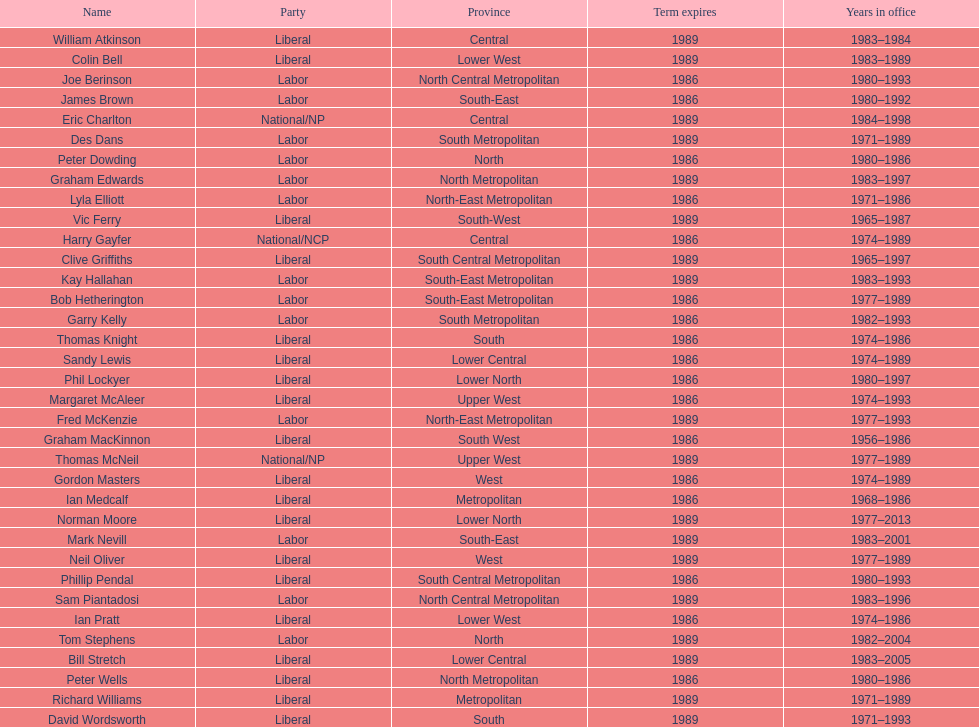Can you parse all the data within this table? {'header': ['Name', 'Party', 'Province', 'Term expires', 'Years in office'], 'rows': [['William Atkinson', 'Liberal', 'Central', '1989', '1983–1984'], ['Colin Bell', 'Liberal', 'Lower West', '1989', '1983–1989'], ['Joe Berinson', 'Labor', 'North Central Metropolitan', '1986', '1980–1993'], ['James Brown', 'Labor', 'South-East', '1986', '1980–1992'], ['Eric Charlton', 'National/NP', 'Central', '1989', '1984–1998'], ['Des Dans', 'Labor', 'South Metropolitan', '1989', '1971–1989'], ['Peter Dowding', 'Labor', 'North', '1986', '1980–1986'], ['Graham Edwards', 'Labor', 'North Metropolitan', '1989', '1983–1997'], ['Lyla Elliott', 'Labor', 'North-East Metropolitan', '1986', '1971–1986'], ['Vic Ferry', 'Liberal', 'South-West', '1989', '1965–1987'], ['Harry Gayfer', 'National/NCP', 'Central', '1986', '1974–1989'], ['Clive Griffiths', 'Liberal', 'South Central Metropolitan', '1989', '1965–1997'], ['Kay Hallahan', 'Labor', 'South-East Metropolitan', '1989', '1983–1993'], ['Bob Hetherington', 'Labor', 'South-East Metropolitan', '1986', '1977–1989'], ['Garry Kelly', 'Labor', 'South Metropolitan', '1986', '1982–1993'], ['Thomas Knight', 'Liberal', 'South', '1986', '1974–1986'], ['Sandy Lewis', 'Liberal', 'Lower Central', '1986', '1974–1989'], ['Phil Lockyer', 'Liberal', 'Lower North', '1986', '1980–1997'], ['Margaret McAleer', 'Liberal', 'Upper West', '1986', '1974–1993'], ['Fred McKenzie', 'Labor', 'North-East Metropolitan', '1989', '1977–1993'], ['Graham MacKinnon', 'Liberal', 'South West', '1986', '1956–1986'], ['Thomas McNeil', 'National/NP', 'Upper West', '1989', '1977–1989'], ['Gordon Masters', 'Liberal', 'West', '1986', '1974–1989'], ['Ian Medcalf', 'Liberal', 'Metropolitan', '1986', '1968–1986'], ['Norman Moore', 'Liberal', 'Lower North', '1989', '1977–2013'], ['Mark Nevill', 'Labor', 'South-East', '1989', '1983–2001'], ['Neil Oliver', 'Liberal', 'West', '1989', '1977–1989'], ['Phillip Pendal', 'Liberal', 'South Central Metropolitan', '1986', '1980–1993'], ['Sam Piantadosi', 'Labor', 'North Central Metropolitan', '1989', '1983–1996'], ['Ian Pratt', 'Liberal', 'Lower West', '1986', '1974–1986'], ['Tom Stephens', 'Labor', 'North', '1989', '1982–2004'], ['Bill Stretch', 'Liberal', 'Lower Central', '1989', '1983–2005'], ['Peter Wells', 'Liberal', 'North Metropolitan', '1986', '1980–1986'], ['Richard Williams', 'Liberal', 'Metropolitan', '1989', '1971–1989'], ['David Wordsworth', 'Liberal', 'South', '1989', '1971–1993']]} What is the number of people in the liberal party? 19. 